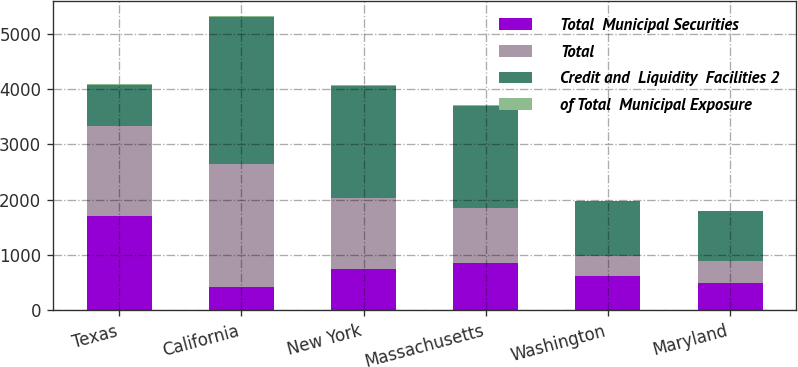Convert chart. <chart><loc_0><loc_0><loc_500><loc_500><stacked_bar_chart><ecel><fcel>Texas<fcel>California<fcel>New York<fcel>Massachusetts<fcel>Washington<fcel>Maryland<nl><fcel>Total  Municipal Securities<fcel>1713<fcel>415<fcel>742<fcel>859<fcel>623<fcel>488<nl><fcel>Total<fcel>1622<fcel>2237<fcel>1288<fcel>991<fcel>366<fcel>411<nl><fcel>Credit and  Liquidity  Facilities 2<fcel>742<fcel>2652<fcel>2030<fcel>1850<fcel>989<fcel>899<nl><fcel>of Total  Municipal Exposure<fcel>18<fcel>14<fcel>11<fcel>10<fcel>5<fcel>5<nl></chart> 